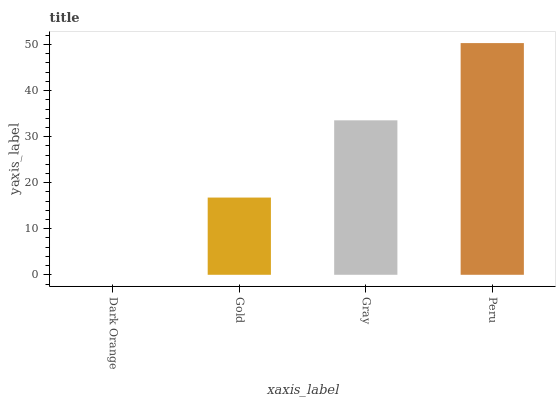Is Dark Orange the minimum?
Answer yes or no. Yes. Is Peru the maximum?
Answer yes or no. Yes. Is Gold the minimum?
Answer yes or no. No. Is Gold the maximum?
Answer yes or no. No. Is Gold greater than Dark Orange?
Answer yes or no. Yes. Is Dark Orange less than Gold?
Answer yes or no. Yes. Is Dark Orange greater than Gold?
Answer yes or no. No. Is Gold less than Dark Orange?
Answer yes or no. No. Is Gray the high median?
Answer yes or no. Yes. Is Gold the low median?
Answer yes or no. Yes. Is Dark Orange the high median?
Answer yes or no. No. Is Dark Orange the low median?
Answer yes or no. No. 